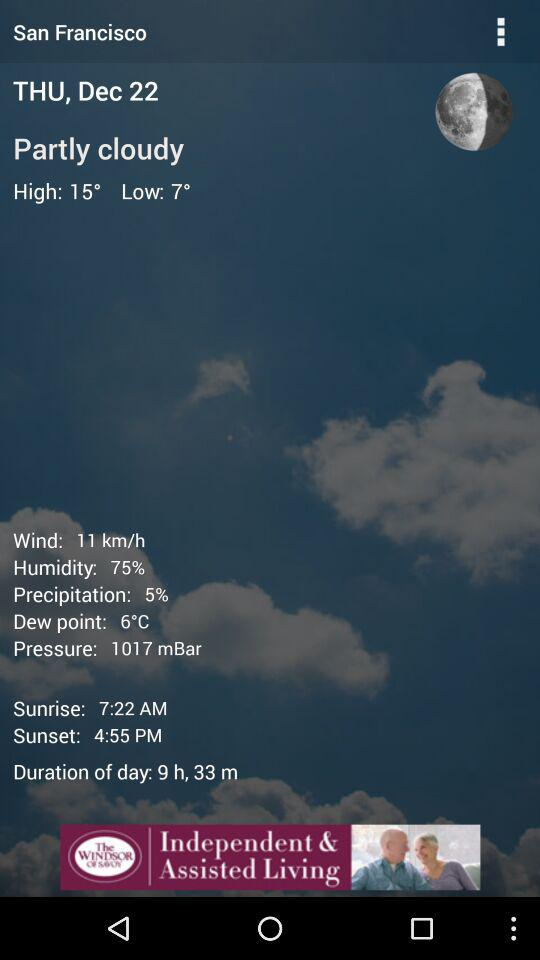What is the high temperature? The high temperature is 15 degrees. 